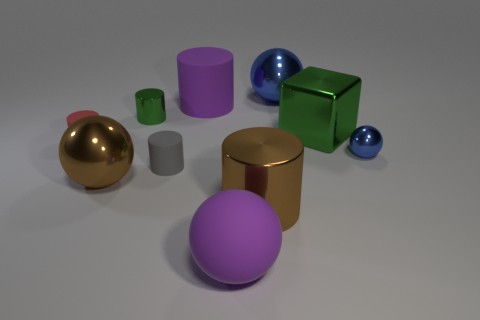Subtract 2 cylinders. How many cylinders are left? 3 Subtract all gray cylinders. How many cylinders are left? 4 Subtract all small red cylinders. How many cylinders are left? 4 Subtract all gray cylinders. Subtract all cyan cubes. How many cylinders are left? 4 Subtract all cubes. How many objects are left? 9 Subtract 0 cyan blocks. How many objects are left? 10 Subtract all green cylinders. Subtract all big brown shiny balls. How many objects are left? 8 Add 9 tiny metallic balls. How many tiny metallic balls are left? 10 Add 5 small metal things. How many small metal things exist? 7 